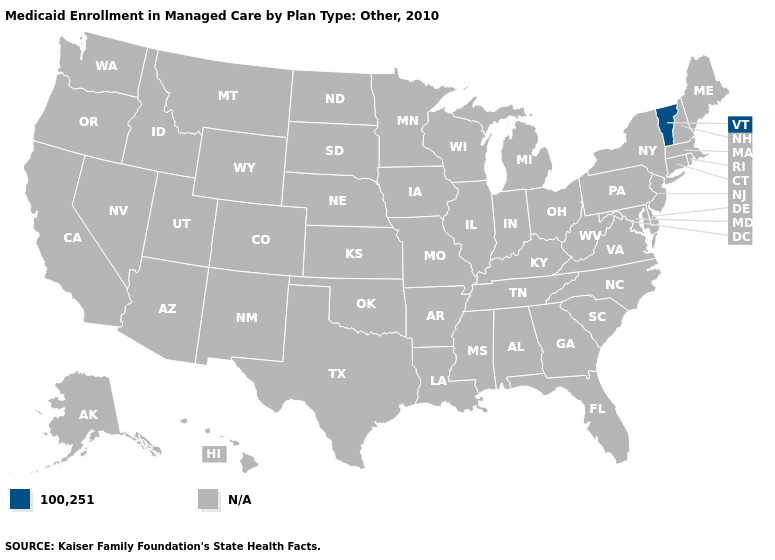What is the value of Iowa?
Give a very brief answer. N/A. What is the value of New Hampshire?
Be succinct. N/A. Does the first symbol in the legend represent the smallest category?
Short answer required. Yes. Is the legend a continuous bar?
Quick response, please. No. What is the highest value in the USA?
Concise answer only. 100,251. Which states have the highest value in the USA?
Give a very brief answer. Vermont. Does the first symbol in the legend represent the smallest category?
Quick response, please. Yes. Does the map have missing data?
Concise answer only. Yes. Which states hav the highest value in the Northeast?
Concise answer only. Vermont. Name the states that have a value in the range N/A?
Short answer required. Alabama, Alaska, Arizona, Arkansas, California, Colorado, Connecticut, Delaware, Florida, Georgia, Hawaii, Idaho, Illinois, Indiana, Iowa, Kansas, Kentucky, Louisiana, Maine, Maryland, Massachusetts, Michigan, Minnesota, Mississippi, Missouri, Montana, Nebraska, Nevada, New Hampshire, New Jersey, New Mexico, New York, North Carolina, North Dakota, Ohio, Oklahoma, Oregon, Pennsylvania, Rhode Island, South Carolina, South Dakota, Tennessee, Texas, Utah, Virginia, Washington, West Virginia, Wisconsin, Wyoming. Is the legend a continuous bar?
Write a very short answer. No. 